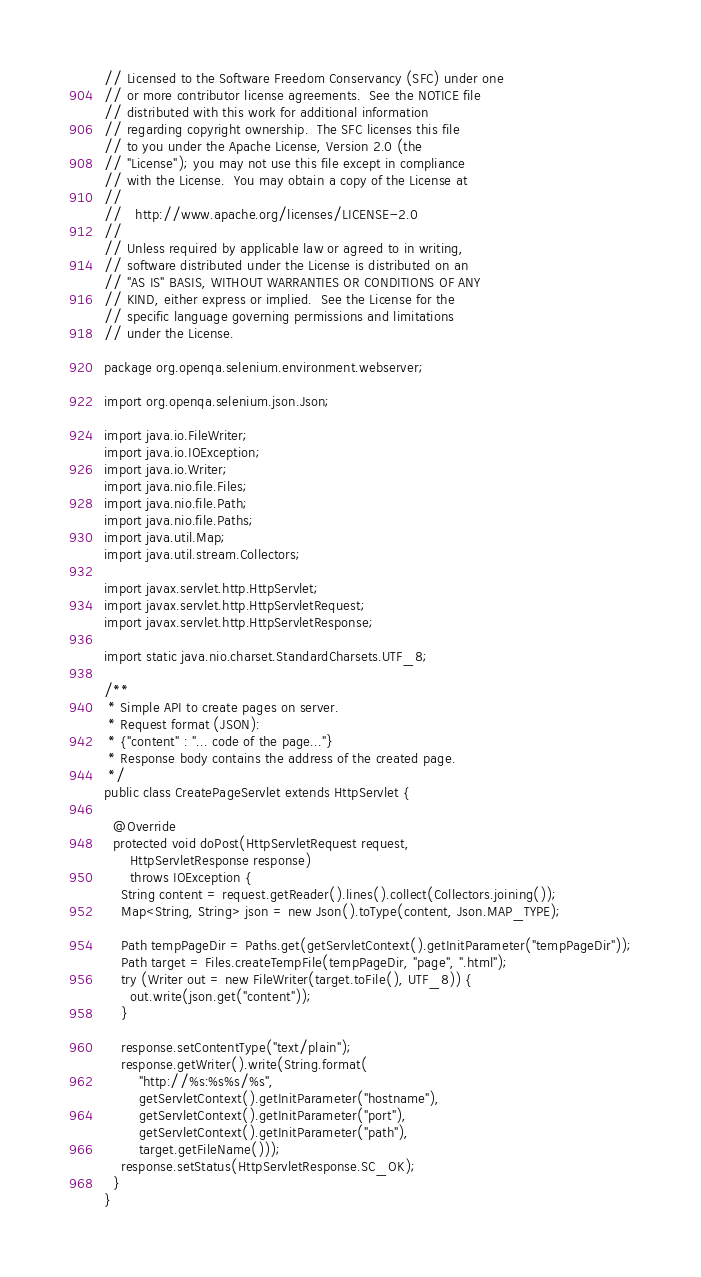Convert code to text. <code><loc_0><loc_0><loc_500><loc_500><_Java_>// Licensed to the Software Freedom Conservancy (SFC) under one
// or more contributor license agreements.  See the NOTICE file
// distributed with this work for additional information
// regarding copyright ownership.  The SFC licenses this file
// to you under the Apache License, Version 2.0 (the
// "License"); you may not use this file except in compliance
// with the License.  You may obtain a copy of the License at
//
//   http://www.apache.org/licenses/LICENSE-2.0
//
// Unless required by applicable law or agreed to in writing,
// software distributed under the License is distributed on an
// "AS IS" BASIS, WITHOUT WARRANTIES OR CONDITIONS OF ANY
// KIND, either express or implied.  See the License for the
// specific language governing permissions and limitations
// under the License.

package org.openqa.selenium.environment.webserver;

import org.openqa.selenium.json.Json;

import java.io.FileWriter;
import java.io.IOException;
import java.io.Writer;
import java.nio.file.Files;
import java.nio.file.Path;
import java.nio.file.Paths;
import java.util.Map;
import java.util.stream.Collectors;

import javax.servlet.http.HttpServlet;
import javax.servlet.http.HttpServletRequest;
import javax.servlet.http.HttpServletResponse;

import static java.nio.charset.StandardCharsets.UTF_8;

/**
 * Simple API to create pages on server.
 * Request format (JSON):
 * {"content" : "... code of the page..."}
 * Response body contains the address of the created page.
 */
public class CreatePageServlet extends HttpServlet {

  @Override
  protected void doPost(HttpServletRequest request,
      HttpServletResponse response)
      throws IOException {
    String content = request.getReader().lines().collect(Collectors.joining());
    Map<String, String> json = new Json().toType(content, Json.MAP_TYPE);

    Path tempPageDir = Paths.get(getServletContext().getInitParameter("tempPageDir"));
    Path target = Files.createTempFile(tempPageDir, "page", ".html");
    try (Writer out = new FileWriter(target.toFile(), UTF_8)) {
      out.write(json.get("content"));
    }

    response.setContentType("text/plain");
    response.getWriter().write(String.format(
        "http://%s:%s%s/%s",
        getServletContext().getInitParameter("hostname"),
        getServletContext().getInitParameter("port"),
        getServletContext().getInitParameter("path"),
        target.getFileName()));
    response.setStatus(HttpServletResponse.SC_OK);
  }
}
</code> 